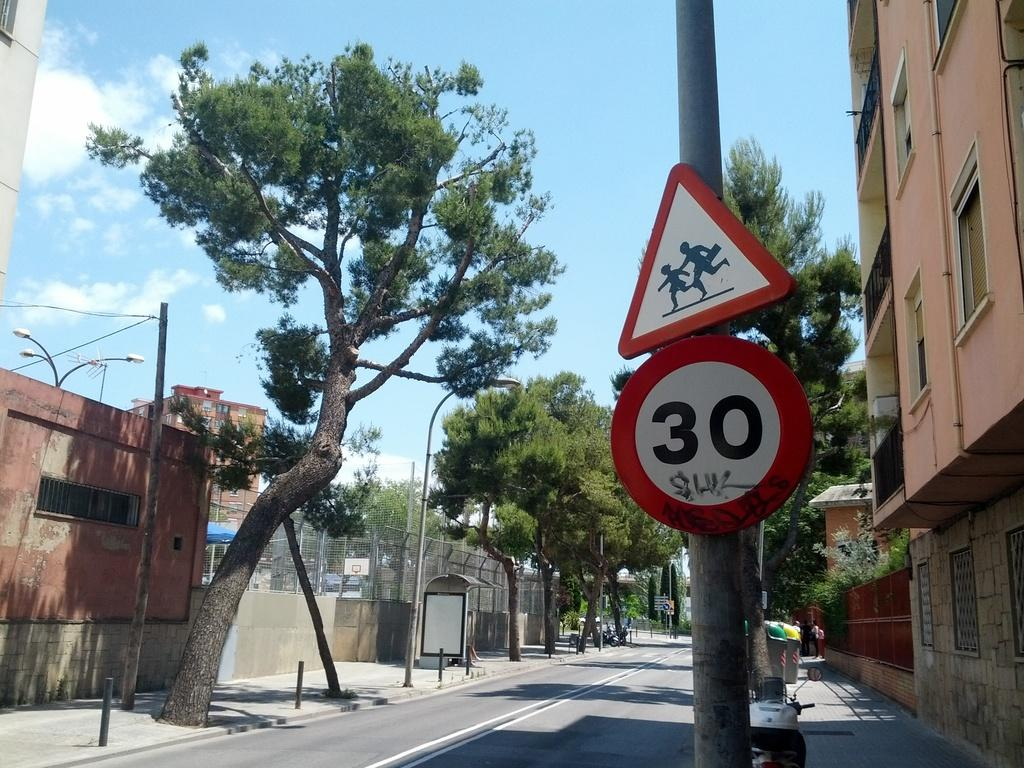<image>
Summarize the visual content of the image. the number 30 that is on a sign below another one outside 